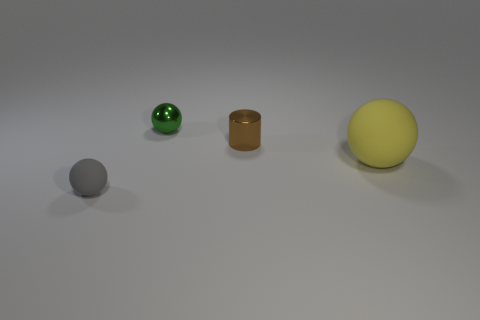Subtract all gray spheres. How many spheres are left? 2 Add 3 big red metal blocks. How many objects exist? 7 Subtract all green balls. How many balls are left? 2 Subtract all cylinders. How many objects are left? 3 Subtract all yellow balls. Subtract all blue cylinders. How many balls are left? 2 Subtract all cyan cylinders. How many gray balls are left? 1 Subtract all gray things. Subtract all small shiny cylinders. How many objects are left? 2 Add 4 cylinders. How many cylinders are left? 5 Add 2 brown shiny things. How many brown shiny things exist? 3 Subtract 0 brown blocks. How many objects are left? 4 